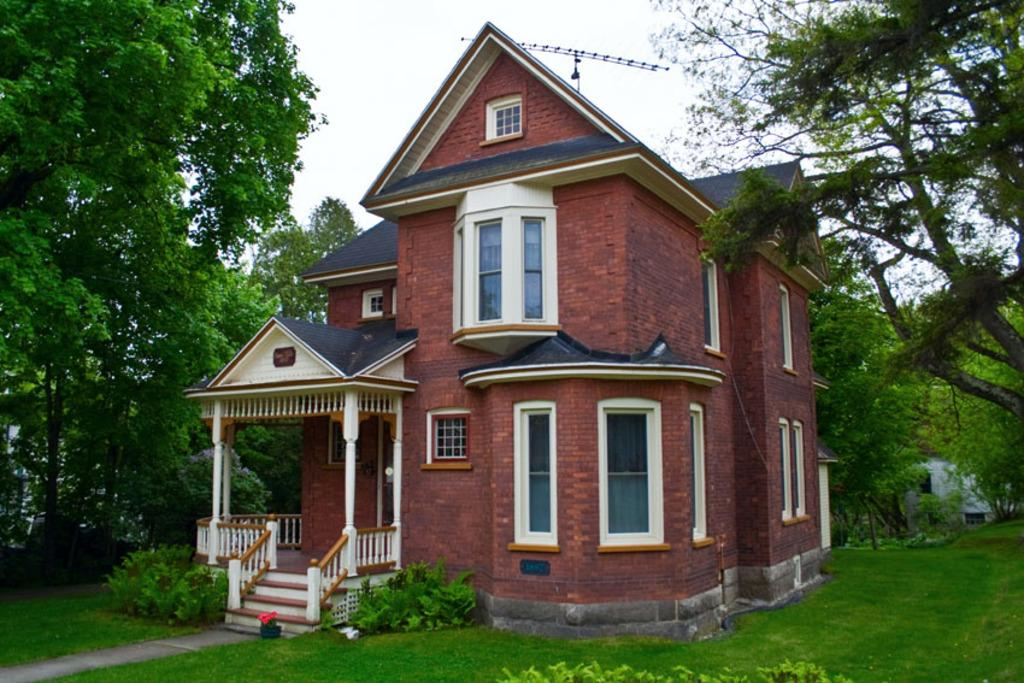What type of house is shown in the image? There is a house with glass windows in the image. What natural elements can be seen in the image? Plants, trees, and grass are visible in the image. What is visible in the background of the image? The sky is visible in the background of the image. Where is the oven located in the image? There is no oven present in the image. What role does the afterthought play in the image? The concept of an afterthought is not applicable to the image, as it is a visual representation of a scene or setting. 